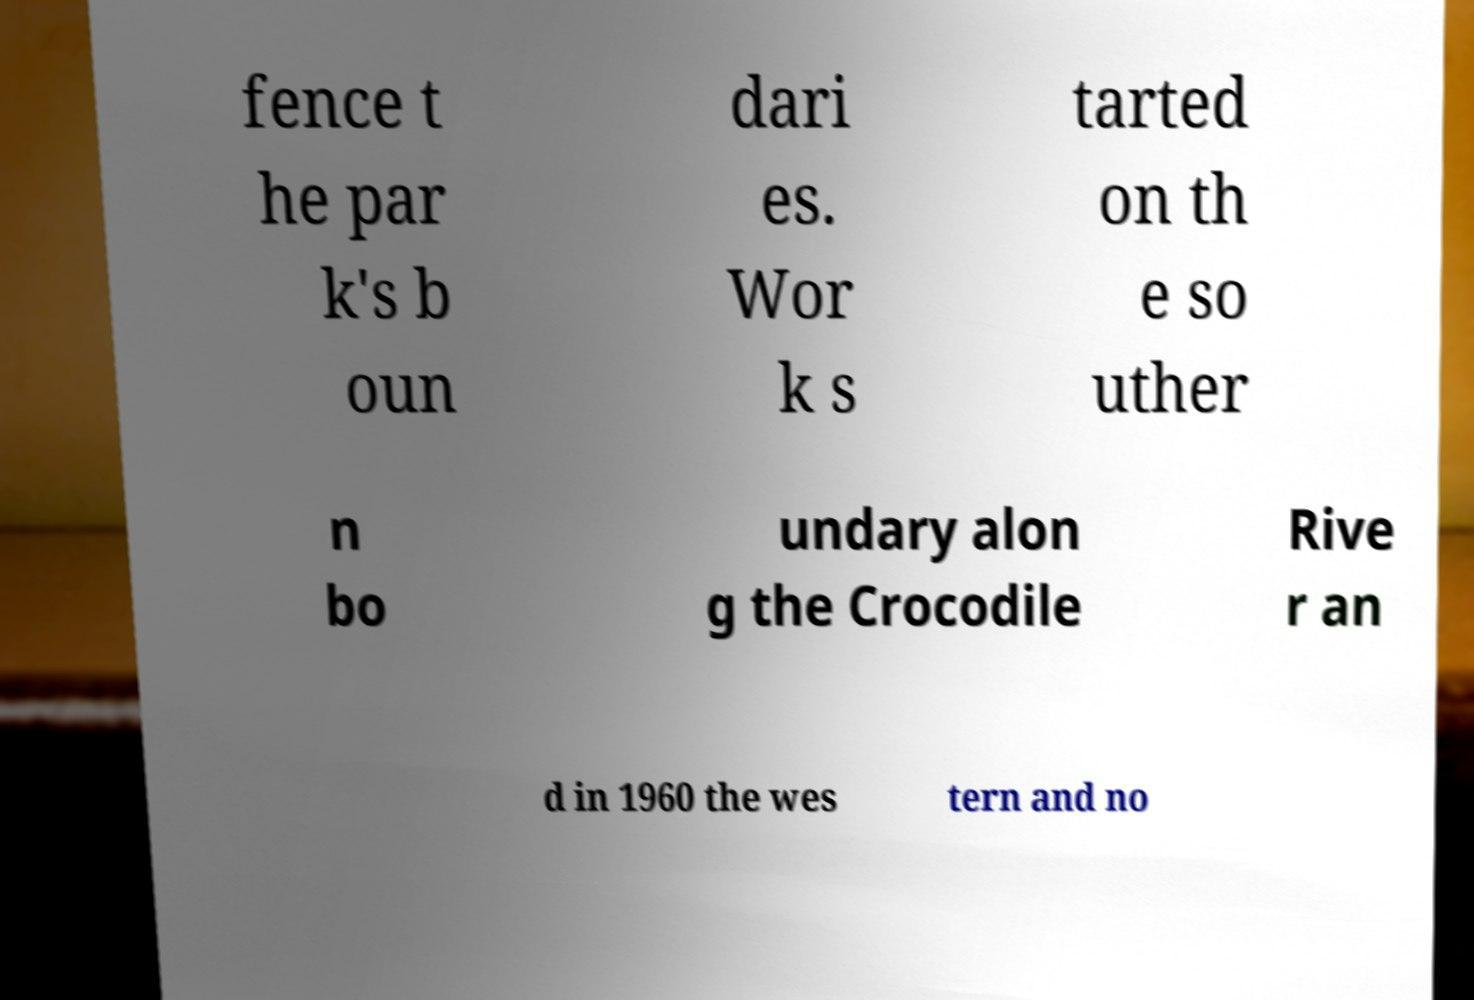There's text embedded in this image that I need extracted. Can you transcribe it verbatim? fence t he par k's b oun dari es. Wor k s tarted on th e so uther n bo undary alon g the Crocodile Rive r an d in 1960 the wes tern and no 